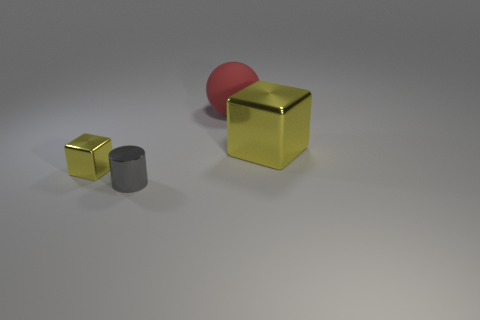Is there anything else that has the same material as the large red object?
Offer a terse response. No. Is there a red object of the same size as the red matte ball?
Give a very brief answer. No. How many other objects are the same material as the red ball?
Give a very brief answer. 0. What color is the shiny object that is both behind the tiny gray object and in front of the big yellow cube?
Your answer should be compact. Yellow. Are the yellow cube that is right of the red sphere and the block that is on the left side of the red object made of the same material?
Make the answer very short. Yes. There is a gray metallic cylinder that is left of the red matte thing; is its size the same as the large yellow object?
Provide a succinct answer. No. There is a shiny cylinder; is it the same color as the metal block on the left side of the large yellow cube?
Ensure brevity in your answer.  No. What is the shape of the small thing that is the same color as the large shiny object?
Offer a very short reply. Cube. The big yellow thing has what shape?
Provide a succinct answer. Cube. Is the rubber sphere the same color as the cylinder?
Keep it short and to the point. No. 